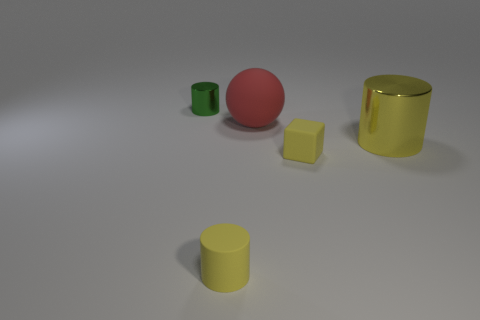What is the size of the cube that is the same material as the big red thing?
Ensure brevity in your answer.  Small. Is there any other thing that has the same color as the big metallic cylinder?
Your response must be concise. Yes. There is a metallic object in front of the big red matte sphere; is it the same color as the rubber object in front of the small yellow matte block?
Provide a succinct answer. Yes. The metallic object to the left of the red matte sphere is what color?
Offer a terse response. Green. There is a object right of the rubber block; does it have the same size as the large red thing?
Keep it short and to the point. Yes. Are there fewer matte cylinders than metallic cylinders?
Give a very brief answer. Yes. There is a tiny rubber object that is the same color as the tiny matte block; what is its shape?
Provide a succinct answer. Cylinder. How many yellow matte cylinders are behind the red rubber object?
Your answer should be very brief. 0. Does the large red object have the same shape as the small metal object?
Offer a terse response. No. What number of rubber objects are in front of the big yellow cylinder and on the left side of the yellow block?
Give a very brief answer. 1. 